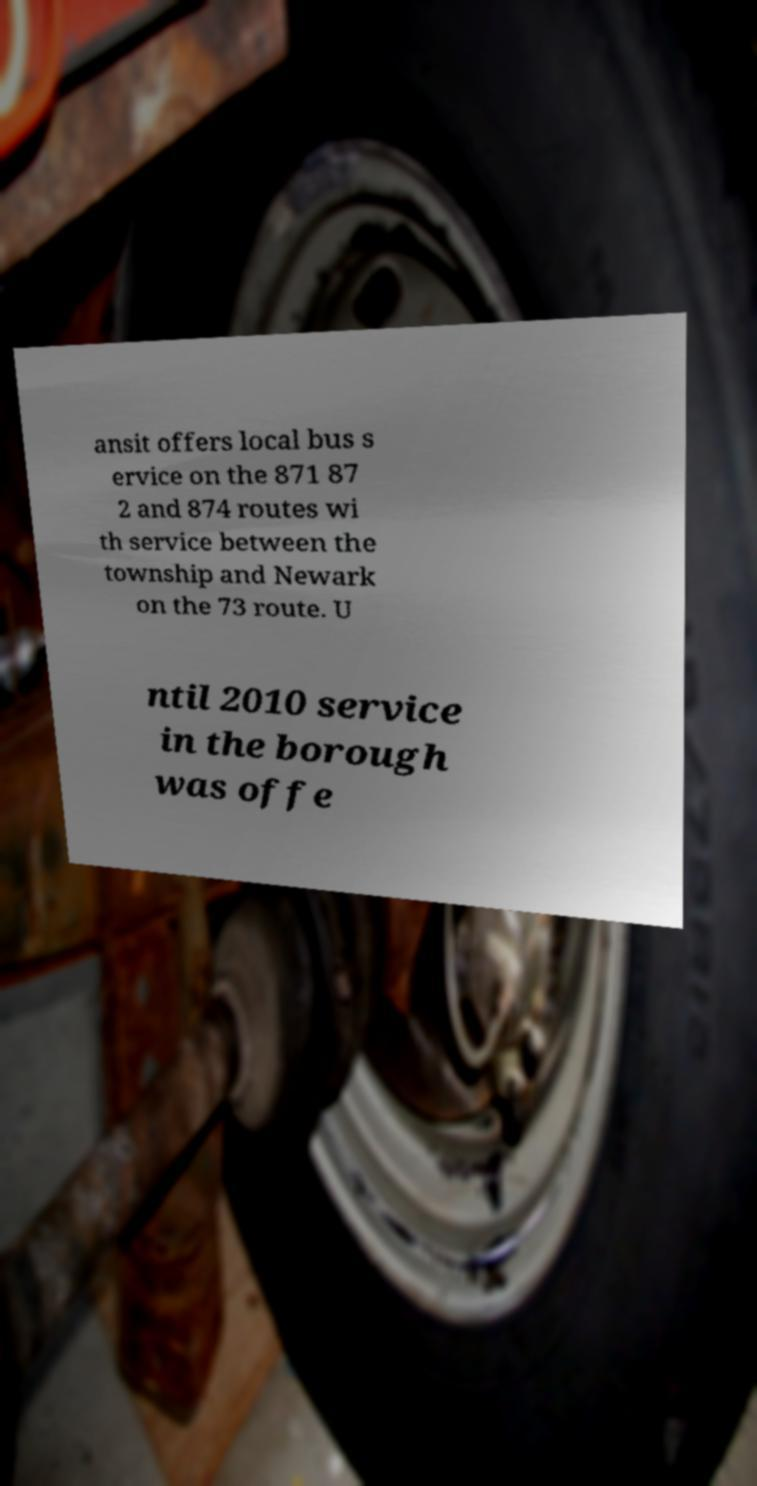Please identify and transcribe the text found in this image. ansit offers local bus s ervice on the 871 87 2 and 874 routes wi th service between the township and Newark on the 73 route. U ntil 2010 service in the borough was offe 